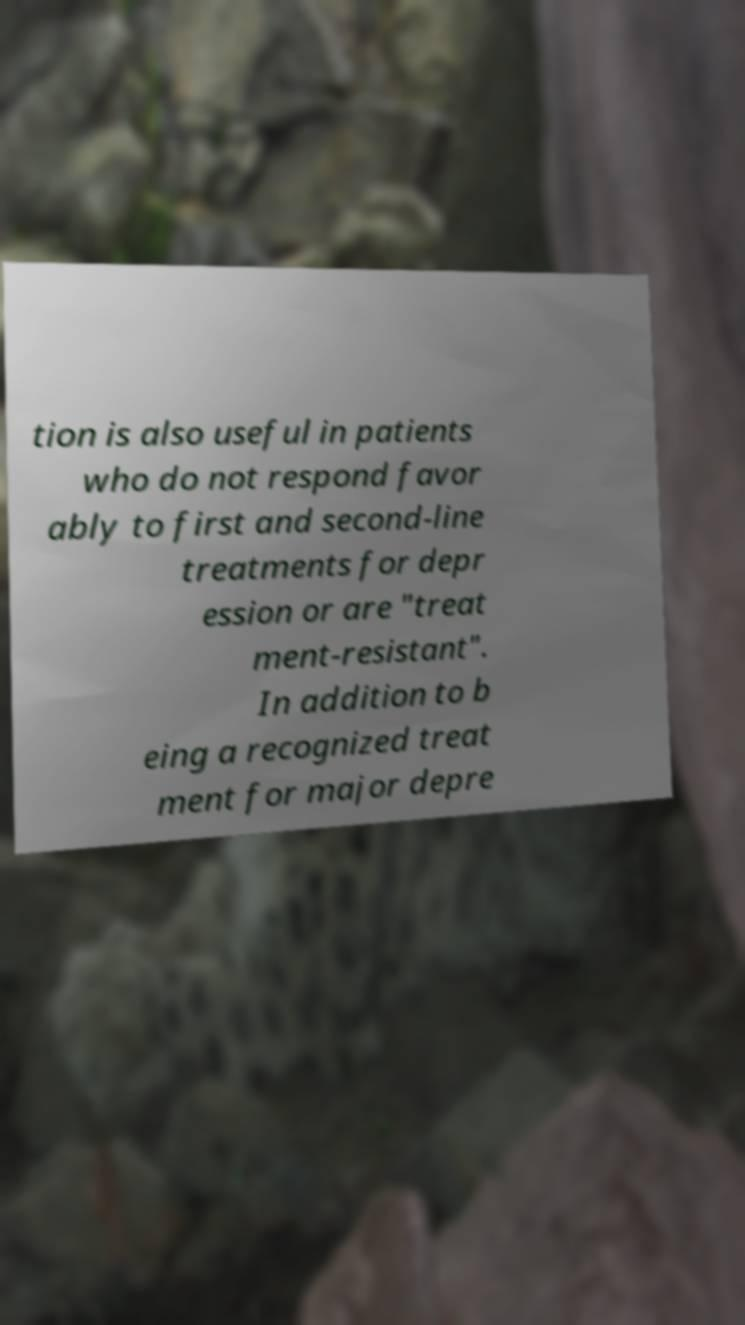For documentation purposes, I need the text within this image transcribed. Could you provide that? tion is also useful in patients who do not respond favor ably to first and second-line treatments for depr ession or are "treat ment-resistant". In addition to b eing a recognized treat ment for major depre 